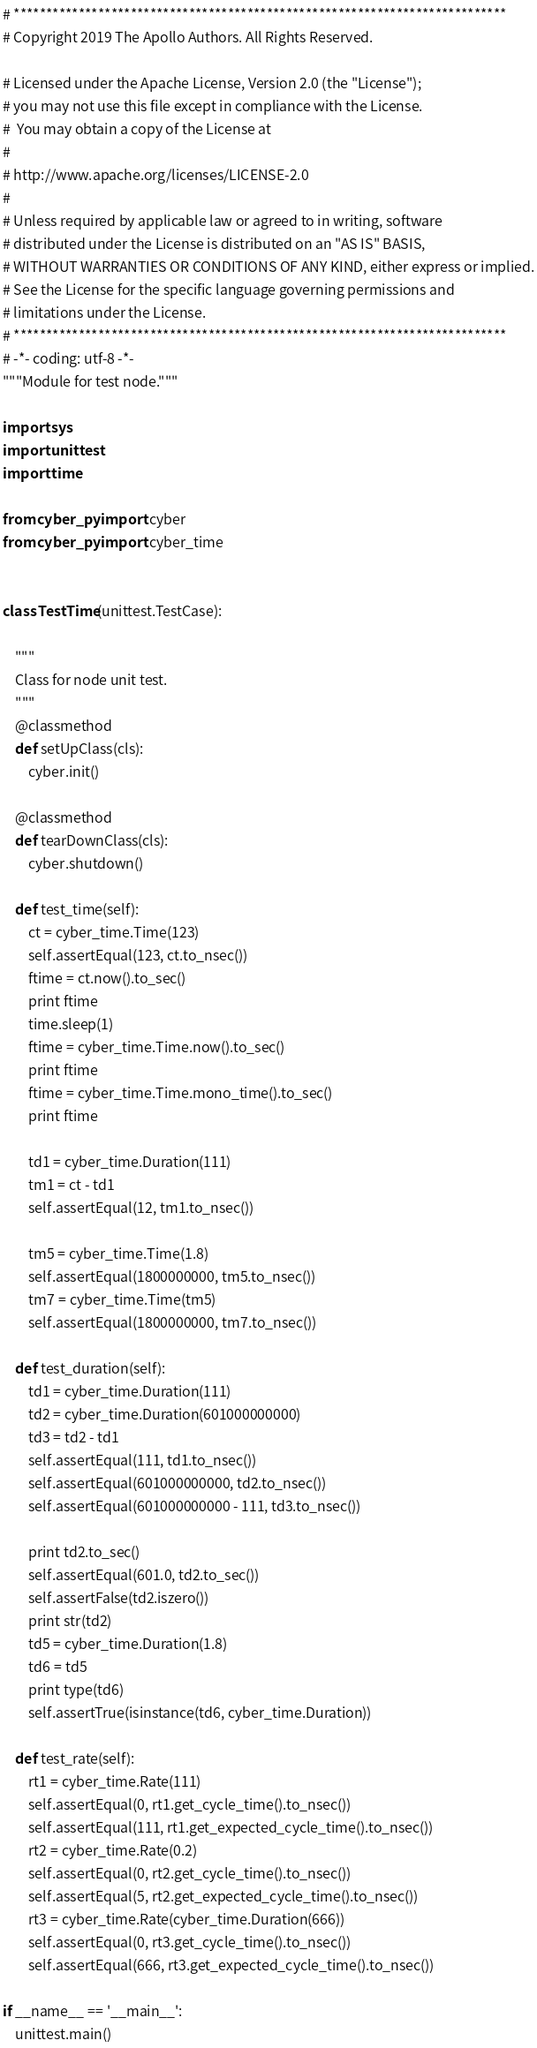Convert code to text. <code><loc_0><loc_0><loc_500><loc_500><_Python_># ****************************************************************************
# Copyright 2019 The Apollo Authors. All Rights Reserved.

# Licensed under the Apache License, Version 2.0 (the "License");
# you may not use this file except in compliance with the License.
#  You may obtain a copy of the License at
#
# http://www.apache.org/licenses/LICENSE-2.0
#
# Unless required by applicable law or agreed to in writing, software
# distributed under the License is distributed on an "AS IS" BASIS,
# WITHOUT WARRANTIES OR CONDITIONS OF ANY KIND, either express or implied.
# See the License for the specific language governing permissions and
# limitations under the License.
# ****************************************************************************
# -*- coding: utf-8 -*-
"""Module for test node."""

import sys
import unittest
import time

from cyber_py import cyber
from cyber_py import cyber_time


class TestTime(unittest.TestCase):

    """
    Class for node unit test.
    """
    @classmethod
    def setUpClass(cls):
        cyber.init()

    @classmethod
    def tearDownClass(cls):
        cyber.shutdown()

    def test_time(self):
        ct = cyber_time.Time(123)
        self.assertEqual(123, ct.to_nsec())
        ftime = ct.now().to_sec()
        print ftime
        time.sleep(1)
        ftime = cyber_time.Time.now().to_sec()
        print ftime
        ftime = cyber_time.Time.mono_time().to_sec()
        print ftime

        td1 = cyber_time.Duration(111)
        tm1 = ct - td1
        self.assertEqual(12, tm1.to_nsec())

        tm5 = cyber_time.Time(1.8)
        self.assertEqual(1800000000, tm5.to_nsec())
        tm7 = cyber_time.Time(tm5)
        self.assertEqual(1800000000, tm7.to_nsec())

    def test_duration(self):
        td1 = cyber_time.Duration(111)
        td2 = cyber_time.Duration(601000000000)
        td3 = td2 - td1
        self.assertEqual(111, td1.to_nsec())
        self.assertEqual(601000000000, td2.to_nsec())
        self.assertEqual(601000000000 - 111, td3.to_nsec())

        print td2.to_sec()
        self.assertEqual(601.0, td2.to_sec())
        self.assertFalse(td2.iszero())
        print str(td2)
        td5 = cyber_time.Duration(1.8)
        td6 = td5
        print type(td6)
        self.assertTrue(isinstance(td6, cyber_time.Duration))

    def test_rate(self):
        rt1 = cyber_time.Rate(111)
        self.assertEqual(0, rt1.get_cycle_time().to_nsec())
        self.assertEqual(111, rt1.get_expected_cycle_time().to_nsec())
        rt2 = cyber_time.Rate(0.2)
        self.assertEqual(0, rt2.get_cycle_time().to_nsec())
        self.assertEqual(5, rt2.get_expected_cycle_time().to_nsec())
        rt3 = cyber_time.Rate(cyber_time.Duration(666))
        self.assertEqual(0, rt3.get_cycle_time().to_nsec())
        self.assertEqual(666, rt3.get_expected_cycle_time().to_nsec())

if __name__ == '__main__':
    unittest.main()
</code> 